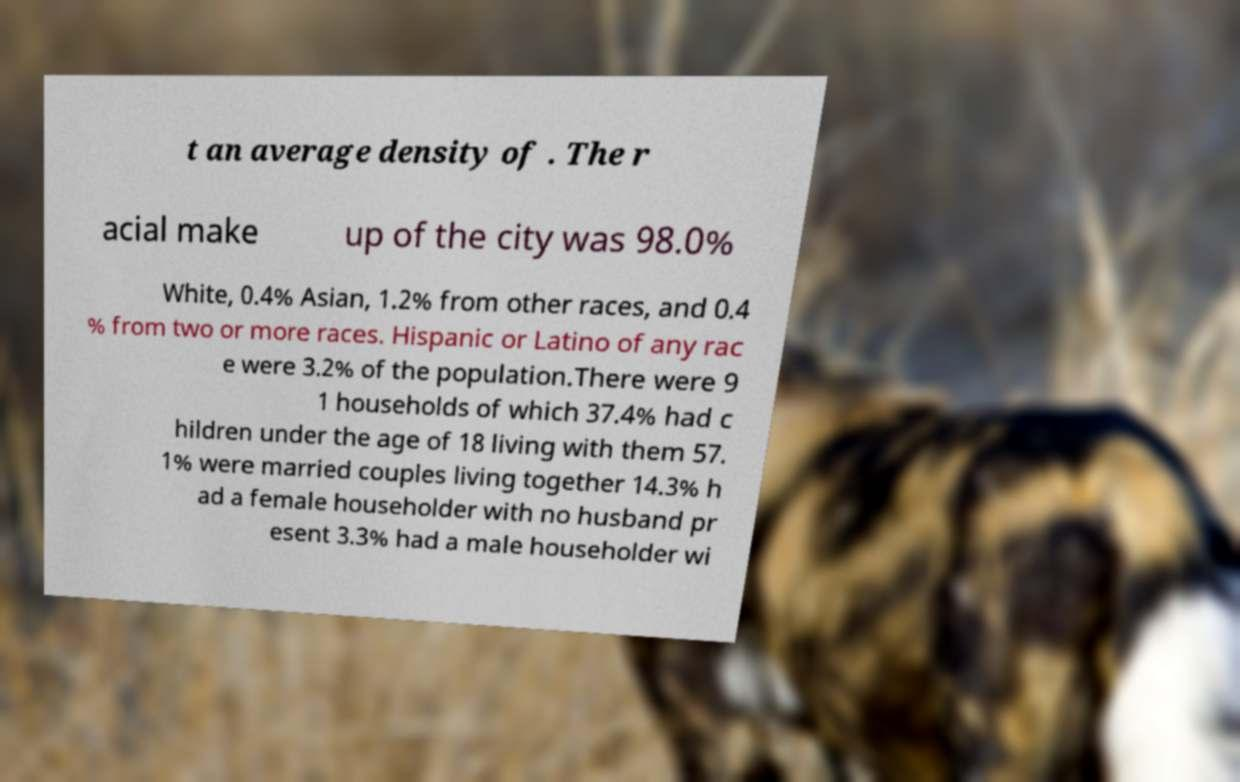Could you assist in decoding the text presented in this image and type it out clearly? t an average density of . The r acial make up of the city was 98.0% White, 0.4% Asian, 1.2% from other races, and 0.4 % from two or more races. Hispanic or Latino of any rac e were 3.2% of the population.There were 9 1 households of which 37.4% had c hildren under the age of 18 living with them 57. 1% were married couples living together 14.3% h ad a female householder with no husband pr esent 3.3% had a male householder wi 